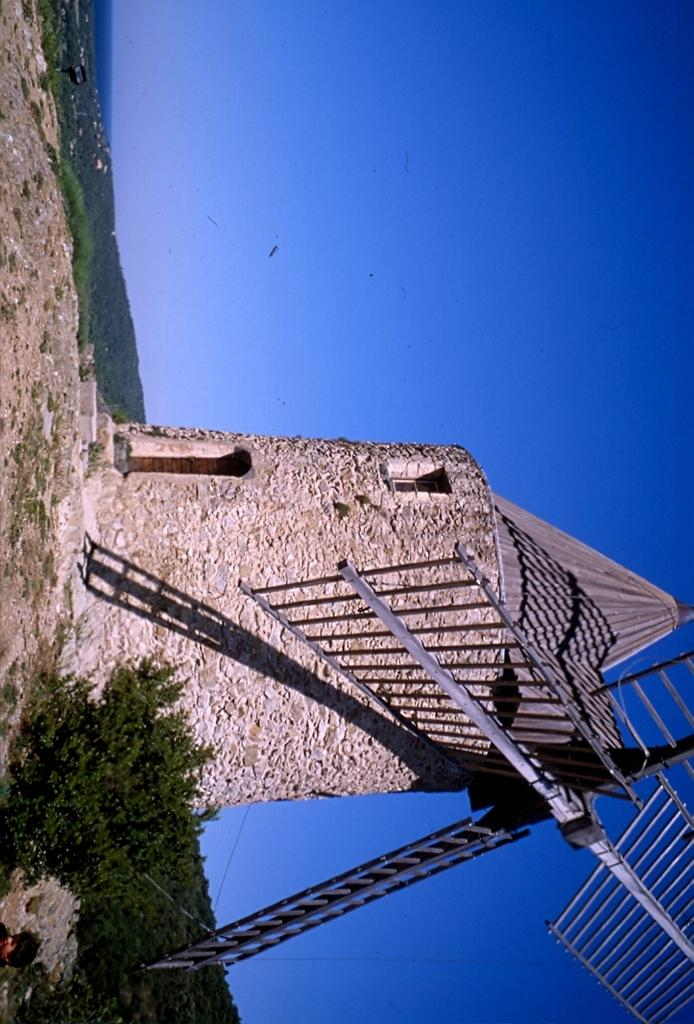What is the main subject in the picture? There is a windmill in the picture. What else can be seen in the picture besides the windmill? There are plants in the picture. What is visible in the background of the picture? The sky is visible in the background of the picture. What type of club can be seen in the picture? There is no club present in the picture; it features a windmill and plants. How many boats are visible in the picture? There are no boats visible in the picture; it features a windmill and plants. 